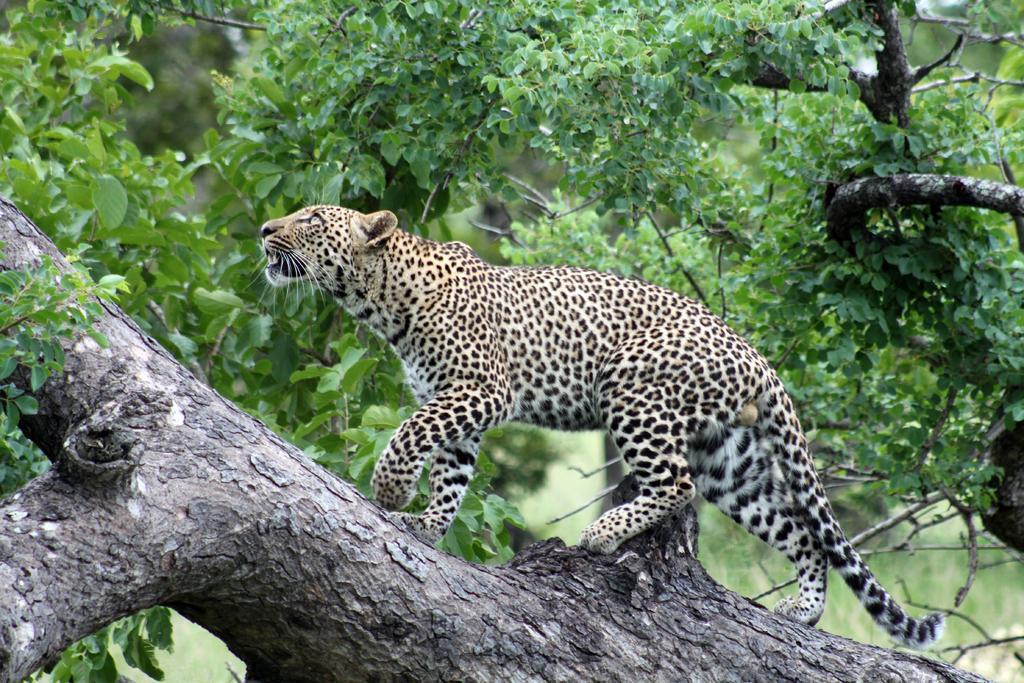In one or two sentences, can you explain what this image depicts? Here we can see a cheetah is walking on a tree. In the background there are trees. 